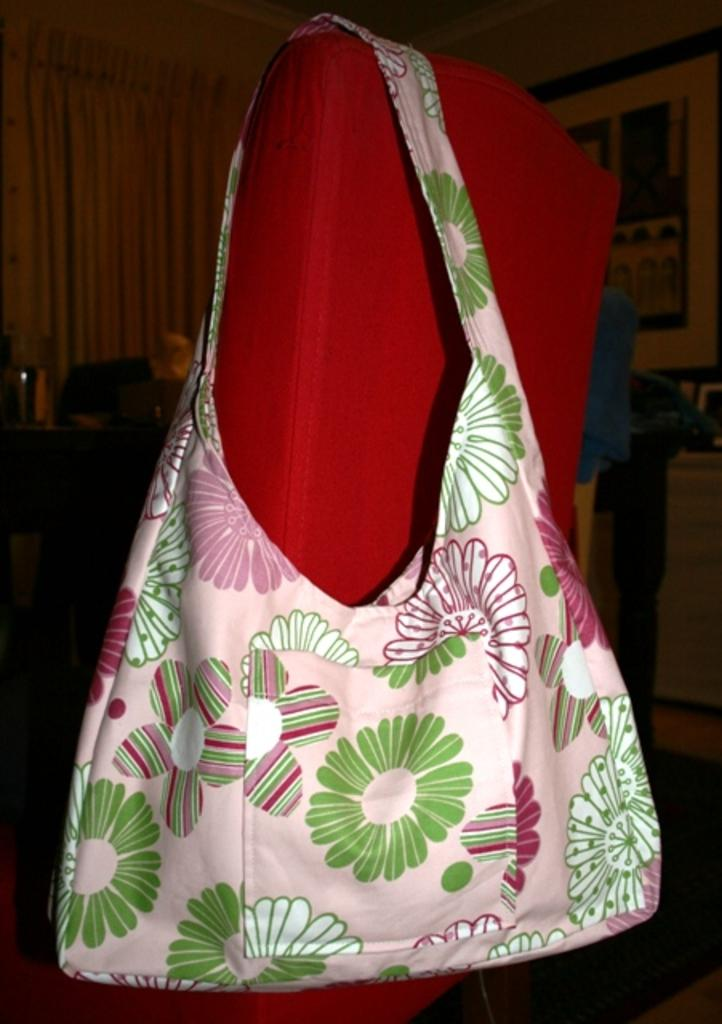What color is the handbag in the image? The handbag in the image is white-colored. Where is the handbag located? The handbag is on a chair. What can be seen in the background of the image? There is a table and a door curtain in the background of the image. What type of setting is depicted in the image? The background appears to be a room in a house. What is the texture of the night in the image? There is no night present in the image, and therefore no texture can be described. 